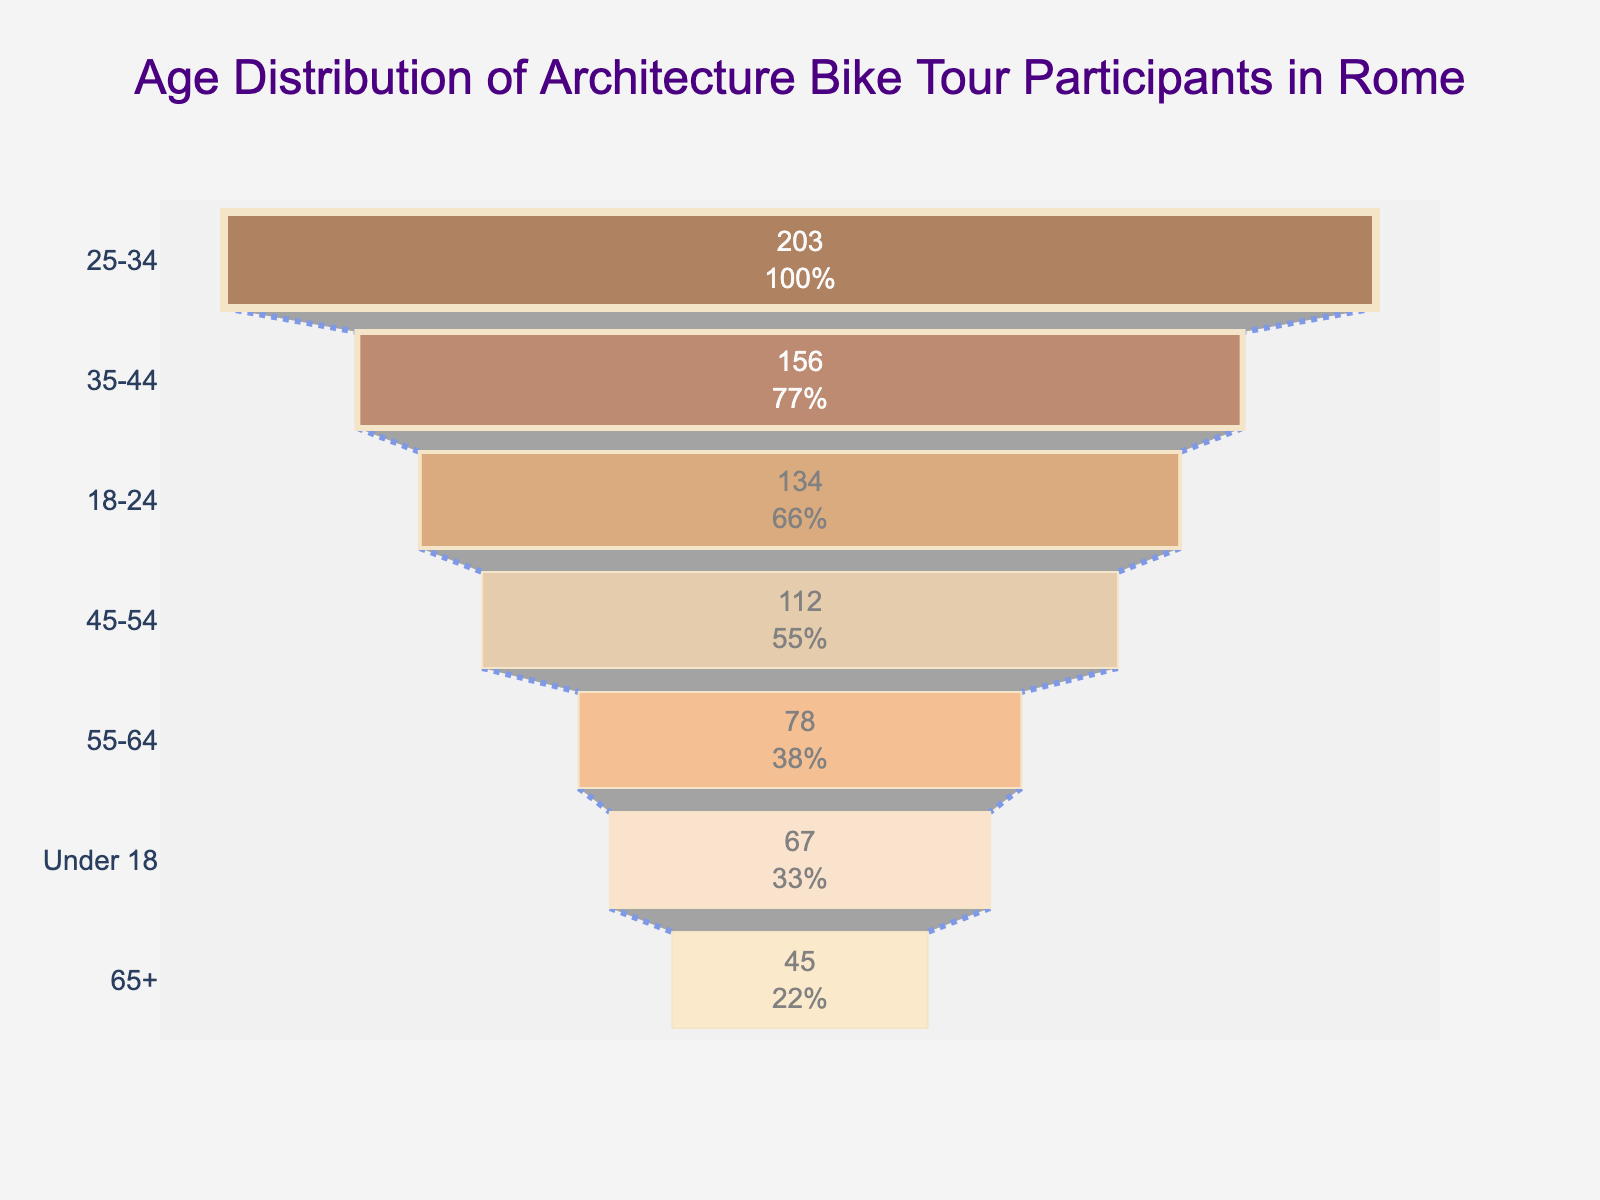What's the title of the figure? The title is typically visible at the top of the figure, giving viewers an immediate sense of what the chart represents. In this case, the title of the figure is "Age Distribution of Architecture Bike Tour Participants in Rome".
Answer: Age Distribution of Architecture Bike Tour Participants in Rome Which age group has the highest number of participants? To find the age group with the highest number of participants, you look for the widest part of the funnel formation, which corresponds to the largest value. The funnel chart indicates that the widest part, representing the group with 203 participants, is the 25-34 age group.
Answer: 25-34 What percentage of participants are in the 35-44 age group? The funnel chart usually includes visual representations of percentages alongside raw numbers. By looking at the "35-44" age group section, you can see the percentage text. The exact portion is visually displayed on the figure as part of the percentage calculation.
Answer: 20.4% How many participants are there in the Under 18 age group compared to the 18-24 age group? To answer this, locate the Under 18 and 18-24 sections of the funnel chart and compare their corresponding values. The Under 18 section has 67 participants, while the 18-24 section has 134 participants.
Answer: 67 in Under 18 and 134 in 18-24 Which age group represents a smaller number of participants, 45-54 or 55-64? To determine which group has fewer participants, compare the values for the 45-54 and 55-64 age groups. The 55-64 age group has 78 participants, which is less than the 112 participants in the 45-54 age group.
Answer: 55-64 What is the combined number of participants under 25 years old? Adding the number of participants in the "Under 18" and "18-24" groups gives a total. The Under 18 group has 67 participants, and the 18-24 group has 134 participants. Therefore, 67 + 134 equals 201 participants.
Answer: 201 Which age group shows the lowest percentage of participants? Observing the smallest segment in the funnel chart helps to identify the age group with the lowest percentage. The section for the 65+ age group is the smallest and thus represents the lowest percentage.
Answer: 65+ What is the difference in the number of participants between the 35-44 and 45-54 age groups? Subtract the number of participants in the 45-54 age group from the number in the 35-44 age group. With 156 participants in the 35-44 group and 112 in the 45-54 group, the difference is 156 - 112 = 44 participants.
Answer: 44 How does the funnel chart depict the transition of participants from age group to age group? The funnel chart visually connects consecutive age groups with lines that show the flow or transition from one group to another. This helps to illustrate how participants are distributed across different age ranges.
Answer: Lines and connector shapes show transitions 